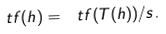Convert formula to latex. <formula><loc_0><loc_0><loc_500><loc_500>\ t f ( h ) = \ t f ( T ( h ) ) / s .</formula> 